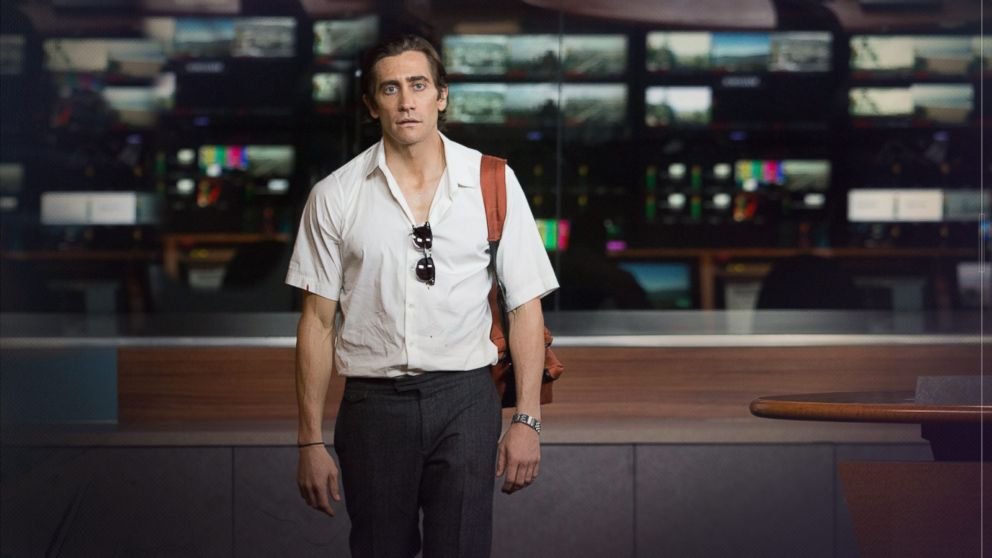Can you describe the main features of this image for me? This image features a man, portrayed by the actor Jake Gyllenhaal as Lou Bloom from the movie 'Nightcrawler.' He stands in a newsroom filled with various broadcasting equipment and screens showcasing vibrant, multicolored displays, which suggest a dynamic and fast-paced environment. He's dressed in a slightly unbuttoned white shirt and gray trousers, conveying a casual yet professional look. His intense gaze and serious expression, paired with the way he carries his sunglasses, add a layer of complexity to his character, reflecting the moral ambiguities and intensity of the film’s themes. 